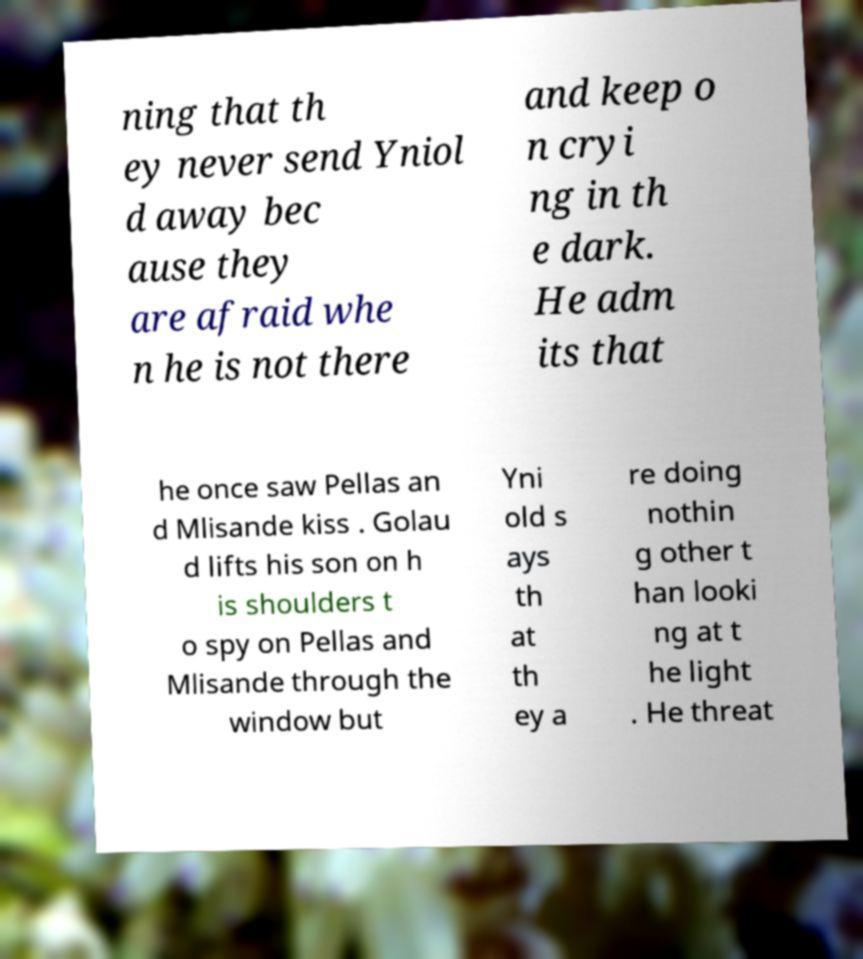Please identify and transcribe the text found in this image. ning that th ey never send Yniol d away bec ause they are afraid whe n he is not there and keep o n cryi ng in th e dark. He adm its that he once saw Pellas an d Mlisande kiss . Golau d lifts his son on h is shoulders t o spy on Pellas and Mlisande through the window but Yni old s ays th at th ey a re doing nothin g other t han looki ng at t he light . He threat 